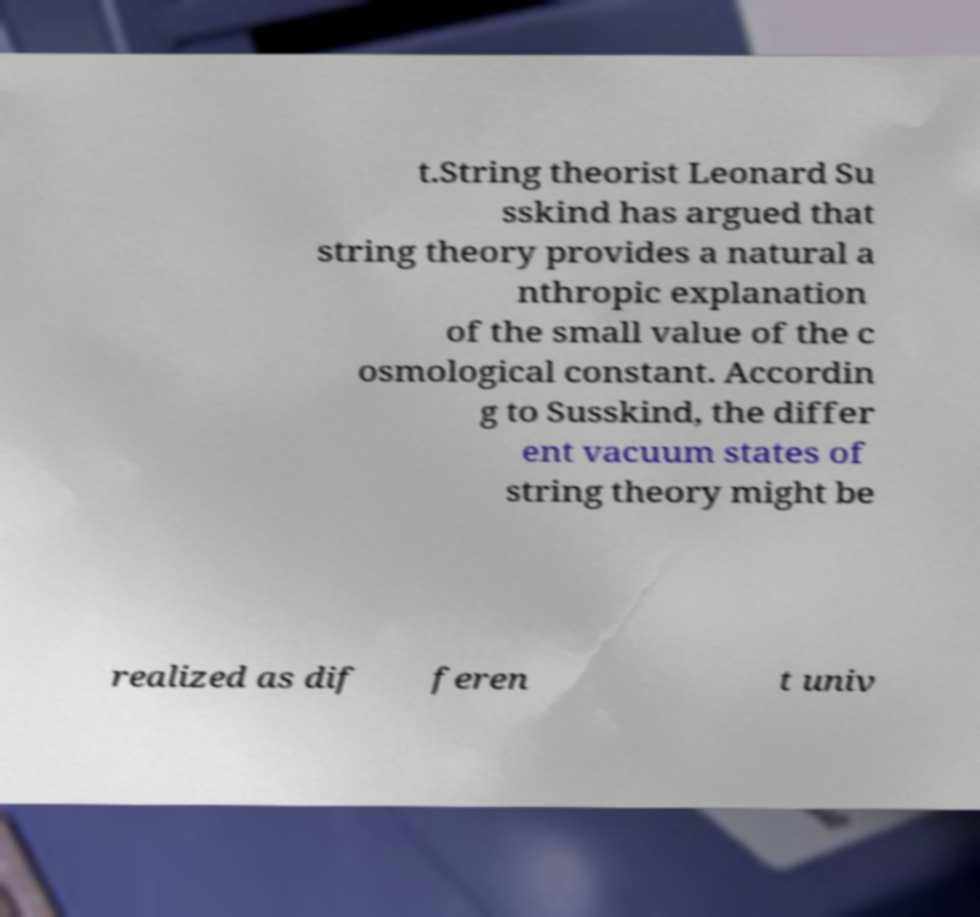Could you assist in decoding the text presented in this image and type it out clearly? t.String theorist Leonard Su sskind has argued that string theory provides a natural a nthropic explanation of the small value of the c osmological constant. Accordin g to Susskind, the differ ent vacuum states of string theory might be realized as dif feren t univ 